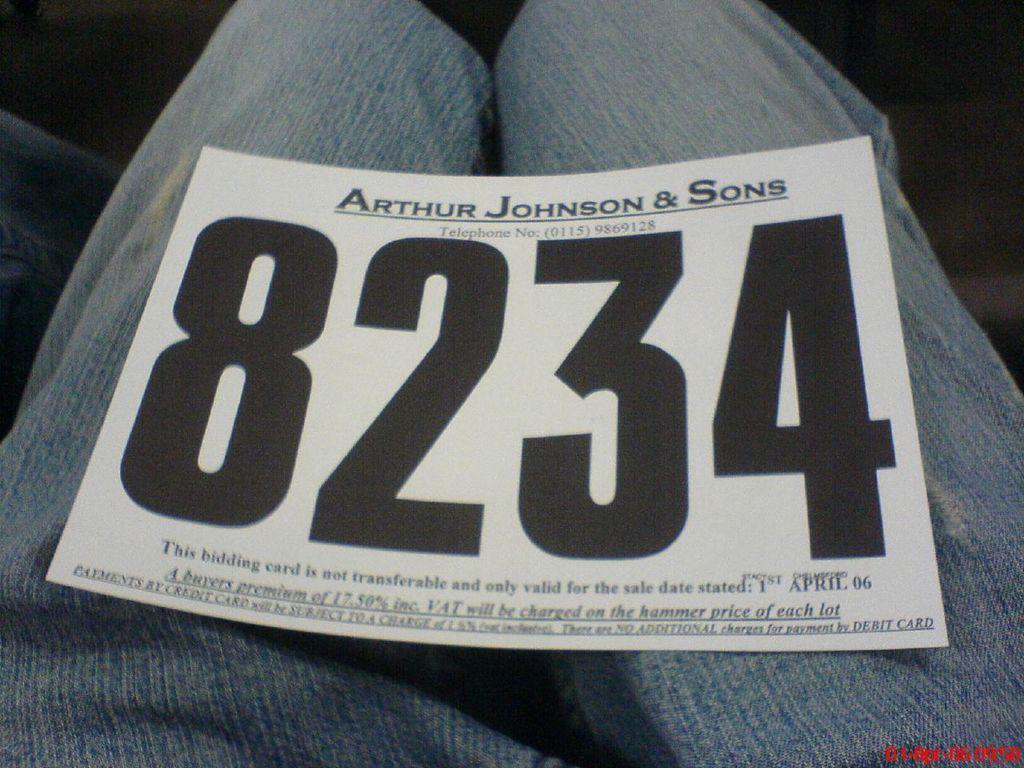Could you give a brief overview of what you see in this image? In this image I can see a paper on the legs of a paper. Some matter is written on it. 